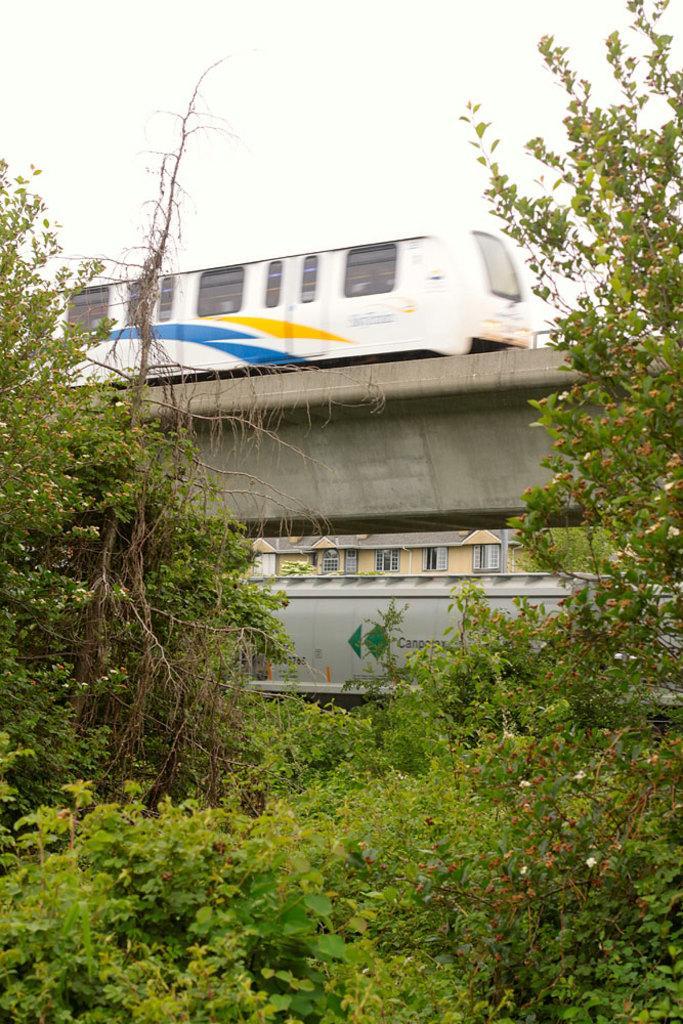Can you describe this image briefly? In the picture I can see a train on a railway track. I can also see trees and plants. In the background I can see the sky. 